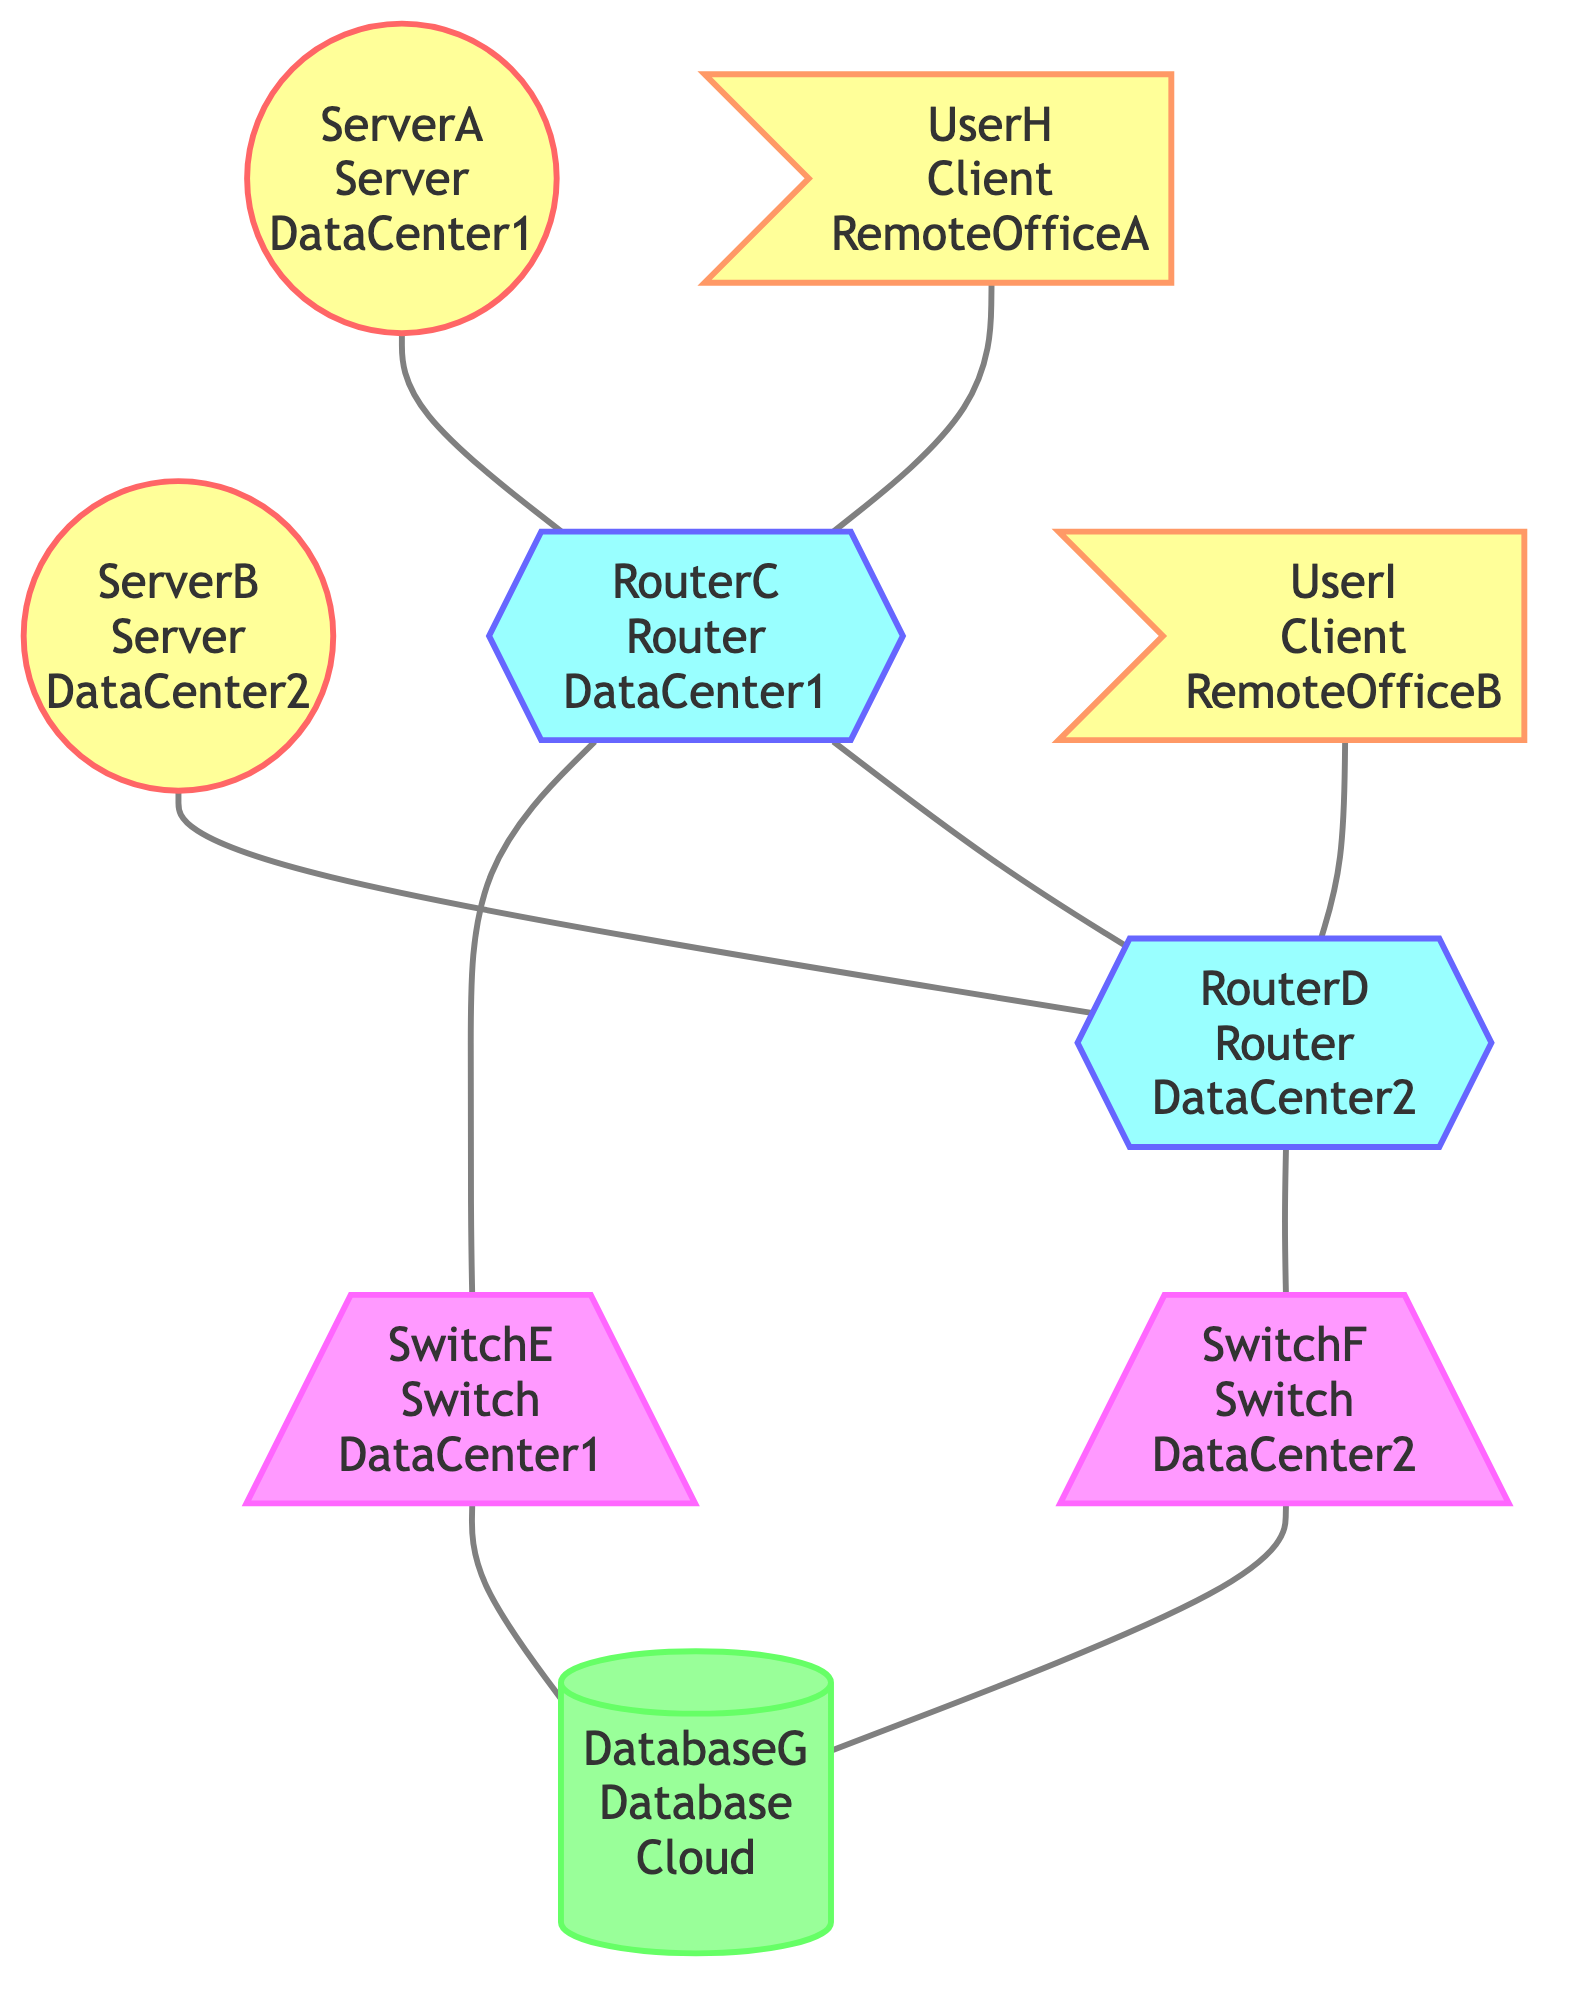What is the total number of nodes in the graph? The graph has 9 nodes listed: ServerA, ServerB, RouterC, RouterD, SwitchE, SwitchF, DatabaseG, UserH, and UserI. By counting each one, we find that there are a total of 9 nodes.
Answer: 9 How many edges connect to DatabaseG? The edges connecting to DatabaseG are: SwitchE to DatabaseG and SwitchF to DatabaseG. There are 2 edges that connect to DatabaseG.
Answer: 2 What type of device is RouterC? RouterC is classified as a Router in the diagram. This classification can be directly identified from node definitions.
Answer: Router Which nodes connect directly to UserH? UserH connects directly to RouterC through a VPN. This relationship is indicated by the edge connecting user nodes to router nodes in the data.
Answer: RouterC What is the total number of connections in the network? By counting all edge definitions, we see the connections are: ServerA to RouterC, ServerB to RouterD, RouterC to SwitchE, RouterD to SwitchF, SwitchE to DatabaseG, SwitchF to DatabaseG, UserH to RouterC, UserI to RouterD, and RouterC to RouterD, amounting to 9 connections total.
Answer: 9 If RouterC fails, how many clients can still connect to the database? The database can still be reached by UserI through RouterD, as well as by any other server that can route through RouterD and SwitchF, ensuring at least one client (UserI) can access the database if RouterC fails.
Answer: 1 Are there any direct links between clients in the diagram? The diagram shows connections only between clients and routers or other devices, without direct links or connections between UserH and UserI, meaning no direct links exist between clients.
Answer: No What is the type of connection between RouterC and RouterD? The connection between RouterC and RouterD is classified as a DirectLink, indicating a specific type of connection between these two router devices.
Answer: DirectLink 